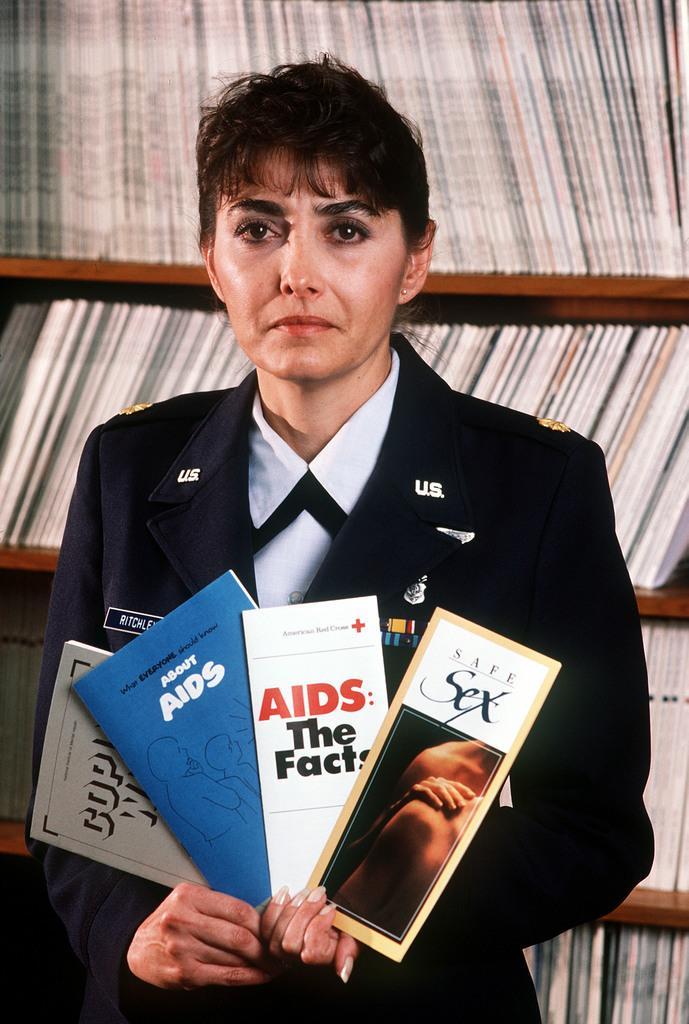Can you describe this image briefly? In the center of the image we can see a woman holding different books. In the background we can see many books in the rack. 